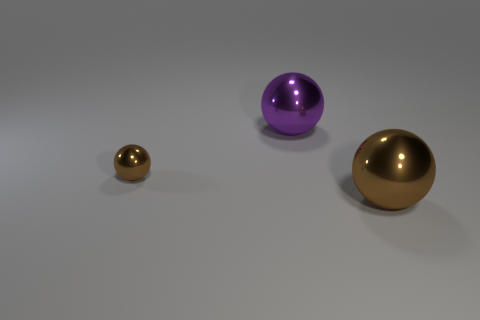How many brown balls must be subtracted to get 1 brown balls? 1 Subtract all red cubes. How many brown balls are left? 2 Add 2 purple balls. How many objects exist? 5 Subtract all small metallic spheres. How many spheres are left? 2 Subtract 1 spheres. How many spheres are left? 2 Add 3 small things. How many small things are left? 4 Add 2 big spheres. How many big spheres exist? 4 Subtract 0 yellow blocks. How many objects are left? 3 Subtract all blue balls. Subtract all green blocks. How many balls are left? 3 Subtract all purple metal things. Subtract all brown metallic balls. How many objects are left? 0 